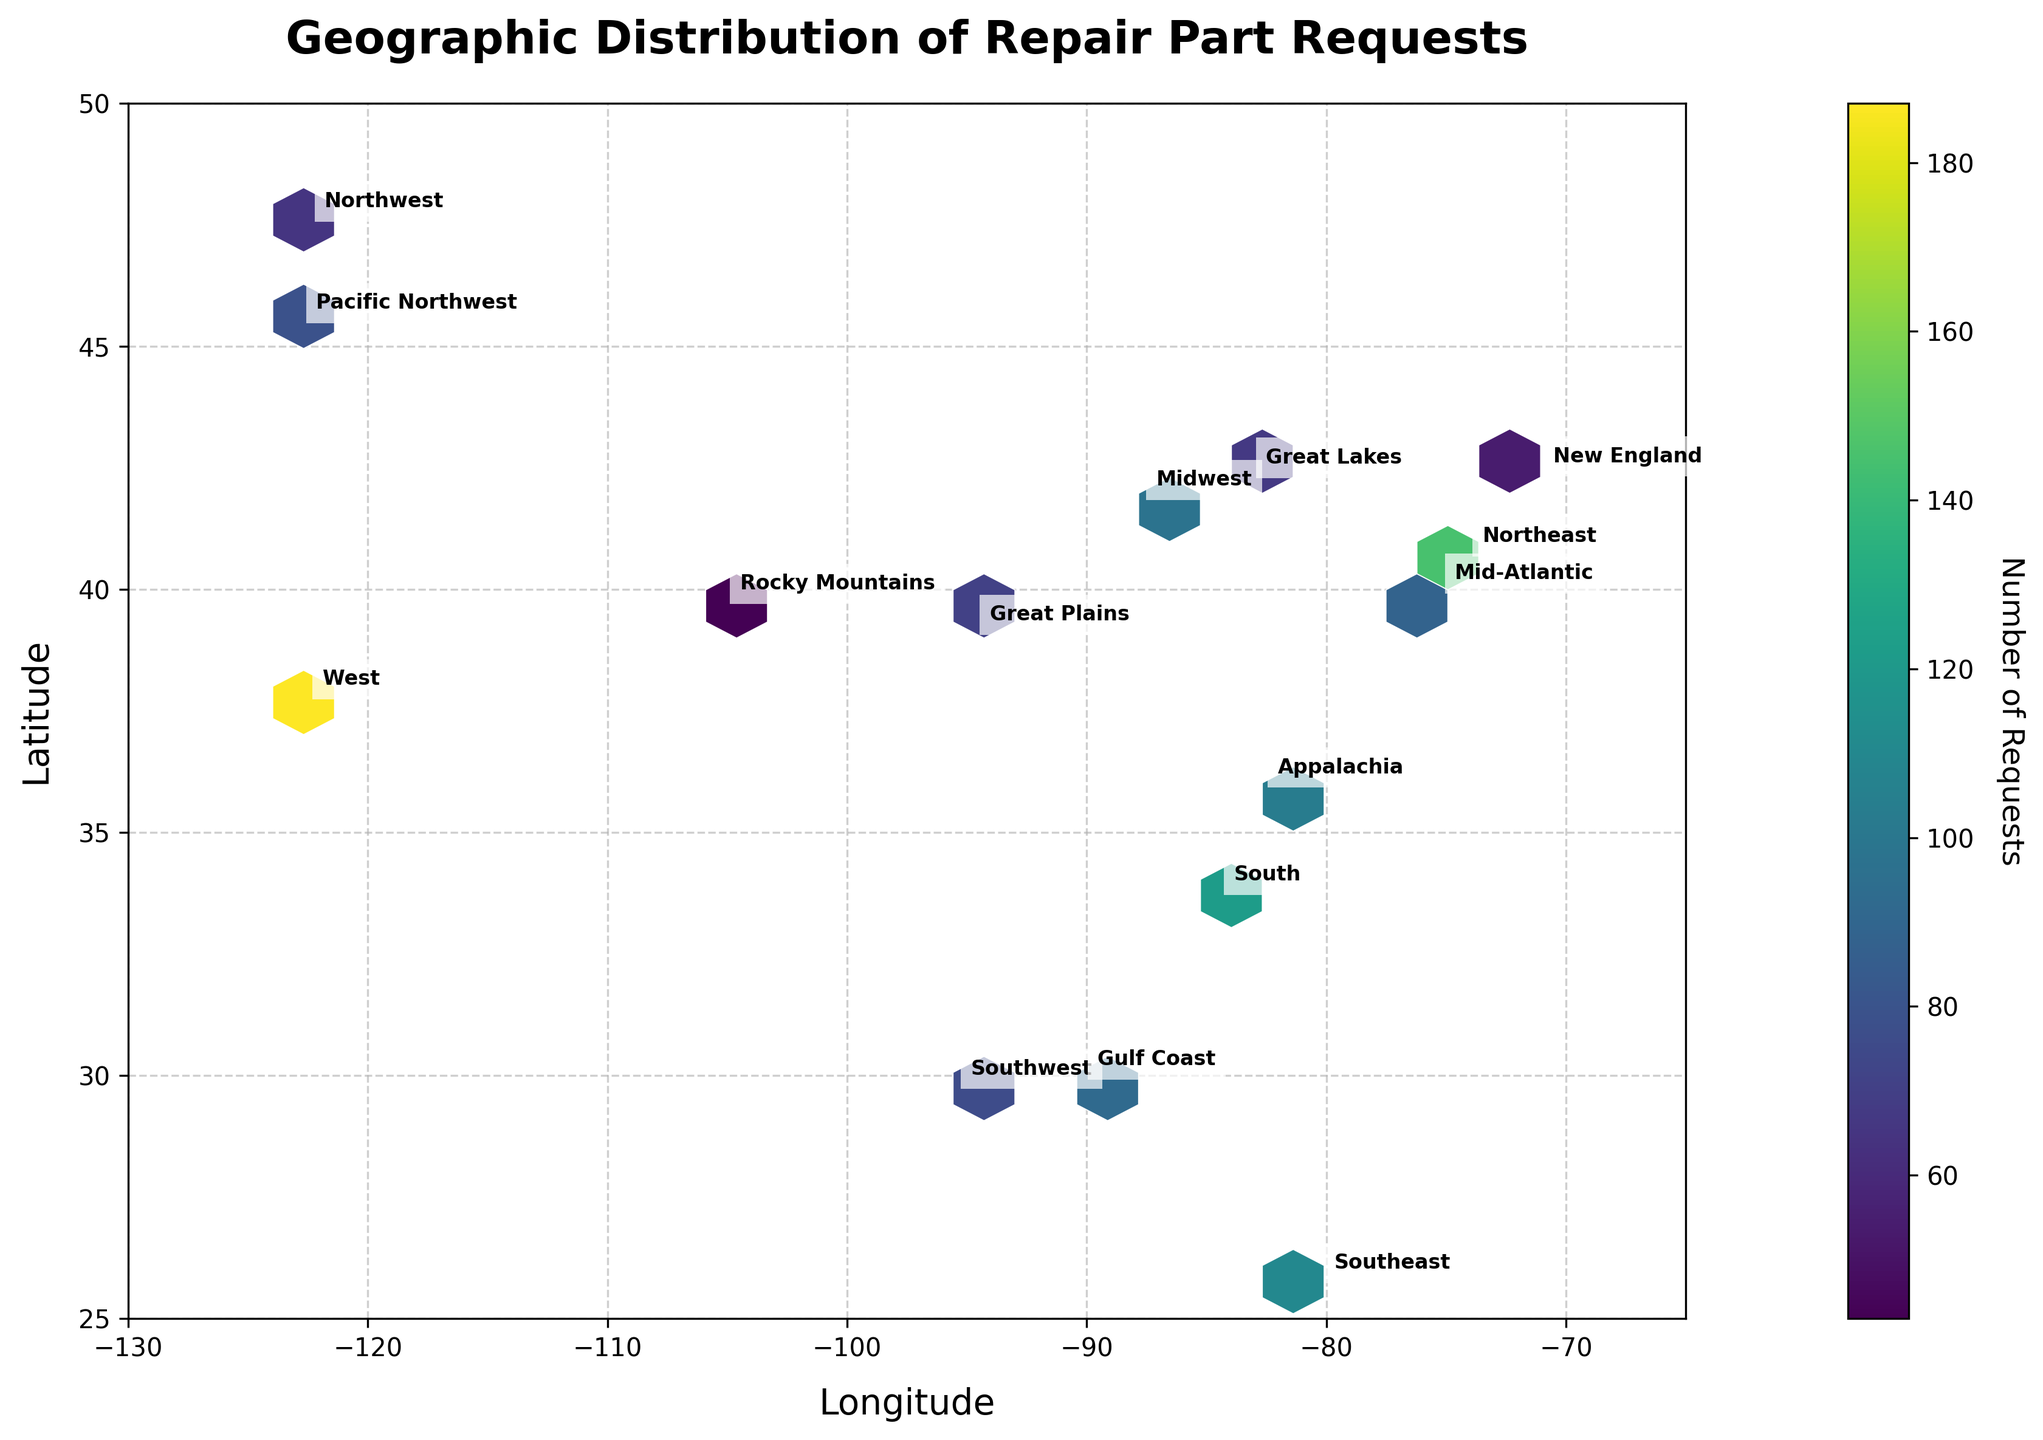Which region shows the highest number of repair part requests? To find the region with the highest number of requests, look at the color intensity on the hexbin plot and identify the coordinates where the color is most intense. Based on the provided data, the West region, represented by San Francisco, has the highest request count with 187 requests.
Answer: West What is the title of the hexbin plot? The title is generally placed at the top center of the plot for easy identification. It summarizes the main subject of the plot. In this case, it reads "Geographic Distribution of Repair Part Requests."
Answer: Geographic Distribution of Repair Part Requests How many regions are represented in the hexbin plot? Regions are indicated by annotated text boxes on the plot at respective geographical locations. Counting all the annotations will give the total number of regions. From the data, there are 15 different regions annotated on the plot.
Answer: 15 Which component type has the lowest number of requests, and in which region is it found? To find the component type with the lowest number of requests, compare the numeric values in the 'Requests' column in the data and then locate the corresponding region. The Rocky Mountains region, represented by Denver, has the lowest number of requests, which are for Fuses with 43 requests.
Answer: Fuses, Rocky Mountains Is there a noticeable cluster of high requests in any specific geographical area? A noticeable cluster of high requests can be identified by looking for densely packed hexes with high color intensity. In the plot, the Western regions, including San Francisco (West region), show a denser cluster of high requests as indicated by the intense color.
Answer: West What is the color representing the bin with 100 requests? Observe the color bar legend to decode the color associated with a specific number of requests. The color corresponding to approximately 100 requests on the legend would be a mid-range color between the extremes shown on the color scale.
Answer: Mid-range color (e.g., green) Which two regions have the closest number of repair part requests? Examine the numbers in the 'Requests' column and identify two values that are numerically closest. The Midwest region (Chicago) with 98 requests and the Mid-Atlantic region (Philadelphia) with 88 requests are the closest in their request counts.
Answer: Midwest and Mid-Atlantic How does the distribution of requests compare between the Northeast and Southeast regions? Compare the color intensity and annotated request numbers for the two specified regions. The Northeast (New York) has 145 requests while the Southeast (Miami) has 110 requests. The color intensity will reflect this difference, with the Northeast being more intense.
Answer: Northeast has more requests What range of latitudes is covered by the plot? Examine the latitude values on the y-axis to determine the span of coverage. Based on the data, the latitude ranges from approximately 25°N to 50°N on the plot.
Answer: 25°N to 50°N Are there any regions where the request numbers are below the median value for all regions? Calculate the median of the request numbers and identify regions with values below this median. The median value can be calculated from the requests as follows: (43, 54, 65, 67, 71, 76, 79, 88, 92, 98, 103, 110, 122, 145, 187). The median is 92. Regions below this median include Rocky Mountains, New England, Northwest, Great Lakes, Great Plains, and Southwest.
Answer: Rocky Mountains, New England, Northwest, Great Lakes, Great Plains, Southwest 